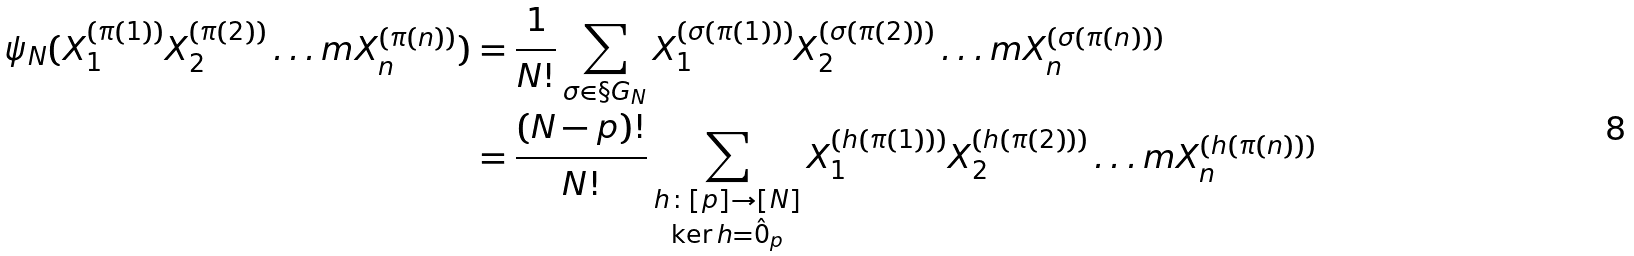Convert formula to latex. <formula><loc_0><loc_0><loc_500><loc_500>\psi _ { N } ( X _ { 1 } ^ { ( \pi ( 1 ) ) } X _ { 2 } ^ { ( \pi ( 2 ) ) } \dots m X _ { n } ^ { ( \pi ( n ) ) } ) & = \frac { 1 } { N ! } \sum _ { \sigma \in \S G _ { N } } X _ { 1 } ^ { ( \sigma ( \pi ( 1 ) ) ) } X _ { 2 } ^ { ( \sigma ( \pi ( 2 ) ) ) } \dots m X _ { n } ^ { ( \sigma ( \pi ( n ) ) ) } \\ & = \frac { ( N - p ) ! } { N ! } \sum _ { \substack { h \colon [ p ] \to [ N ] \\ \ker h = \hat { 0 } _ { p } } } X _ { 1 } ^ { ( h ( \pi ( 1 ) ) ) } X _ { 2 } ^ { ( h ( \pi ( 2 ) ) ) } \dots m X _ { n } ^ { ( h ( \pi ( n ) ) ) }</formula> 